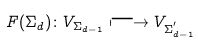<formula> <loc_0><loc_0><loc_500><loc_500>F ( \Sigma _ { d } ) \colon V _ { \Sigma _ { d - 1 } } \longmapsto V _ { \Sigma _ { d - 1 } ^ { ^ { \prime } } }</formula> 